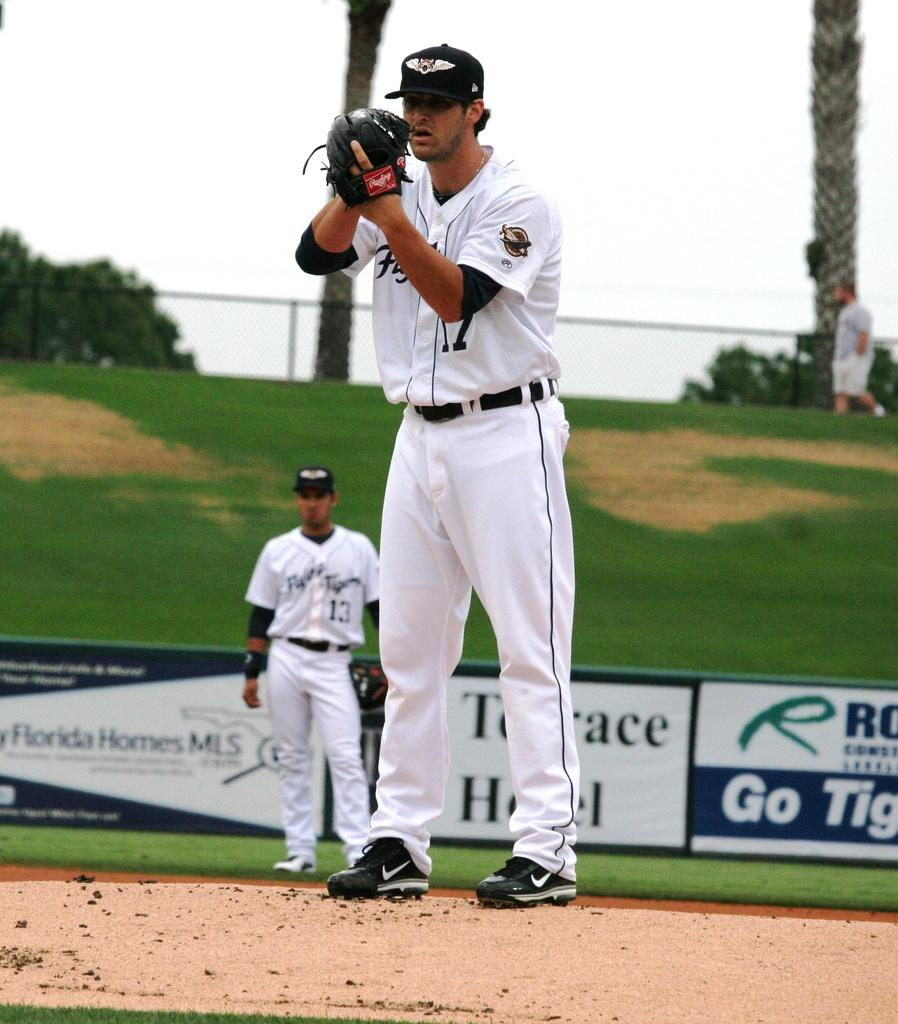Provide a one-sentence caption for the provided image. a pitcher on the mound on a baseball field with a sign for Florida Home MLS. 